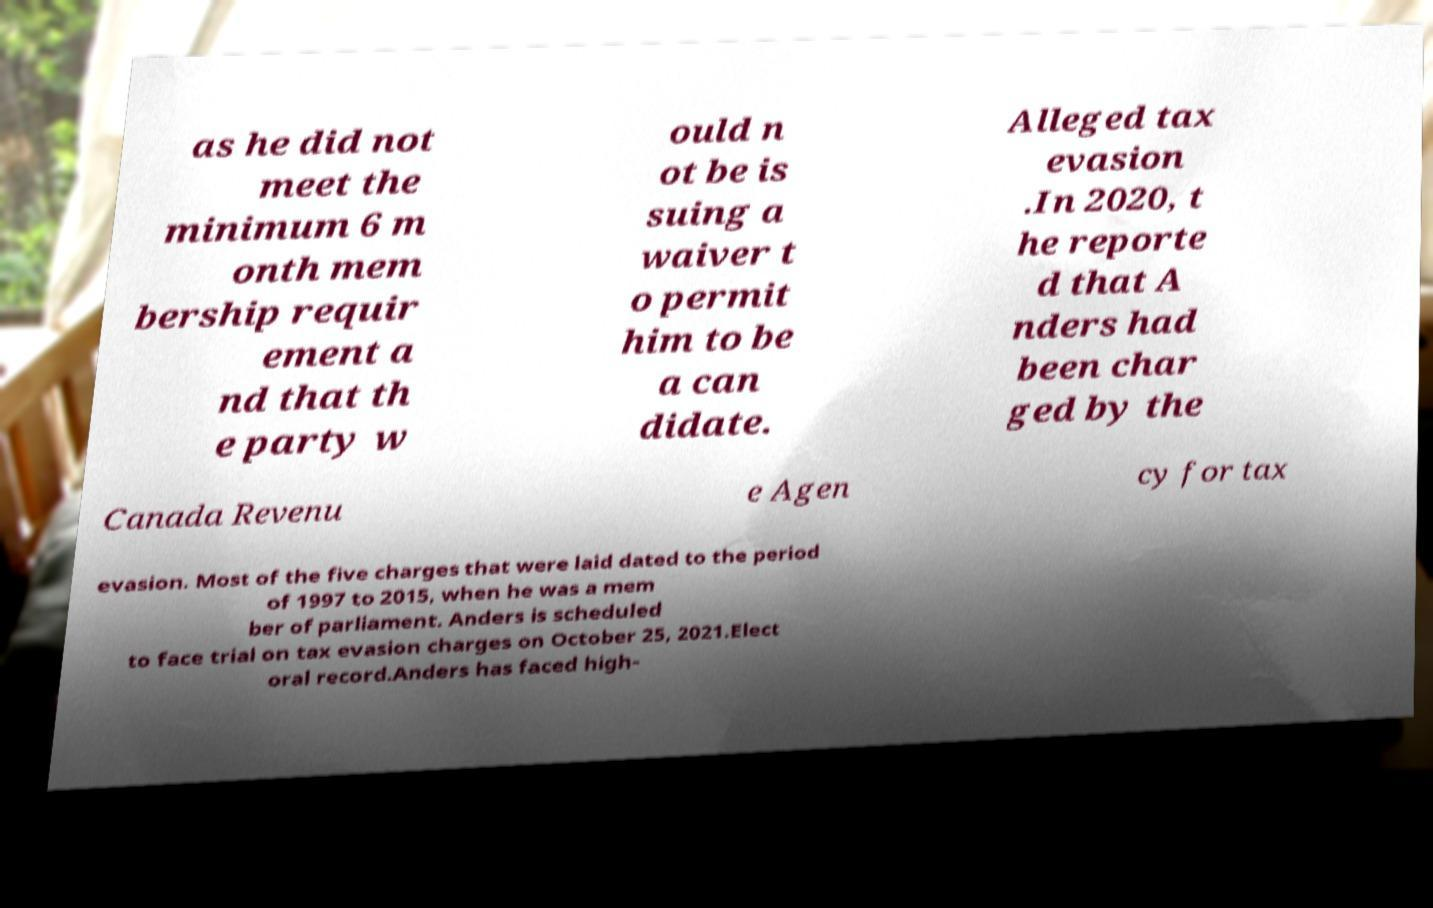What messages or text are displayed in this image? I need them in a readable, typed format. as he did not meet the minimum 6 m onth mem bership requir ement a nd that th e party w ould n ot be is suing a waiver t o permit him to be a can didate. Alleged tax evasion .In 2020, t he reporte d that A nders had been char ged by the Canada Revenu e Agen cy for tax evasion. Most of the five charges that were laid dated to the period of 1997 to 2015, when he was a mem ber of parliament. Anders is scheduled to face trial on tax evasion charges on October 25, 2021.Elect oral record.Anders has faced high- 